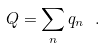<formula> <loc_0><loc_0><loc_500><loc_500>Q = \sum _ { n } q _ { n } \ .</formula> 